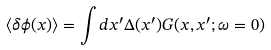Convert formula to latex. <formula><loc_0><loc_0><loc_500><loc_500>\langle \delta \phi ( x ) \rangle = \int d x ^ { \prime } \Delta ( x ^ { \prime } ) G ( x , x ^ { \prime } ; \omega = 0 )</formula> 